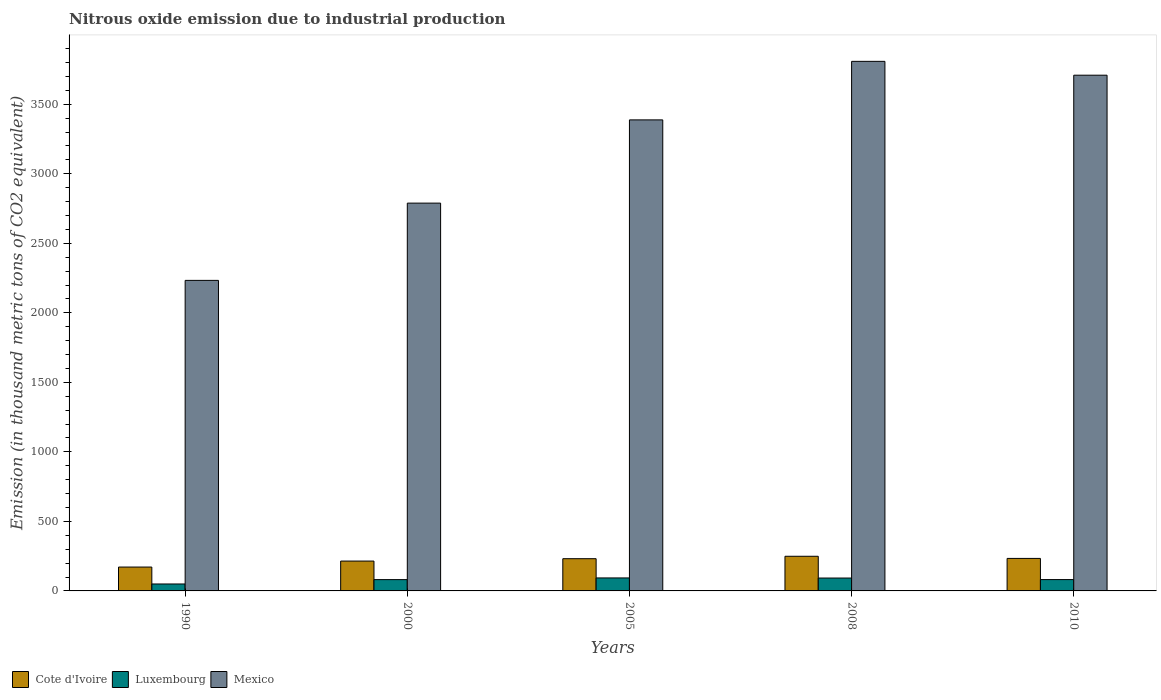What is the label of the 1st group of bars from the left?
Your answer should be very brief. 1990. In how many cases, is the number of bars for a given year not equal to the number of legend labels?
Make the answer very short. 0. What is the amount of nitrous oxide emitted in Mexico in 2000?
Ensure brevity in your answer.  2789.1. Across all years, what is the maximum amount of nitrous oxide emitted in Mexico?
Provide a succinct answer. 3808.7. Across all years, what is the minimum amount of nitrous oxide emitted in Cote d'Ivoire?
Your answer should be very brief. 171.6. In which year was the amount of nitrous oxide emitted in Mexico maximum?
Offer a terse response. 2008. What is the total amount of nitrous oxide emitted in Luxembourg in the graph?
Give a very brief answer. 398.7. What is the difference between the amount of nitrous oxide emitted in Mexico in 2008 and that in 2010?
Make the answer very short. 99.5. What is the difference between the amount of nitrous oxide emitted in Luxembourg in 2000 and the amount of nitrous oxide emitted in Cote d'Ivoire in 2010?
Your answer should be very brief. -152.5. What is the average amount of nitrous oxide emitted in Mexico per year?
Offer a terse response. 3185.64. In the year 2008, what is the difference between the amount of nitrous oxide emitted in Luxembourg and amount of nitrous oxide emitted in Cote d'Ivoire?
Make the answer very short. -156.6. What is the ratio of the amount of nitrous oxide emitted in Luxembourg in 2005 to that in 2008?
Your answer should be compact. 1.01. What is the difference between the highest and the second highest amount of nitrous oxide emitted in Mexico?
Your answer should be compact. 99.5. What is the difference between the highest and the lowest amount of nitrous oxide emitted in Cote d'Ivoire?
Ensure brevity in your answer.  77.6. In how many years, is the amount of nitrous oxide emitted in Luxembourg greater than the average amount of nitrous oxide emitted in Luxembourg taken over all years?
Provide a short and direct response. 4. What does the 3rd bar from the right in 2005 represents?
Provide a short and direct response. Cote d'Ivoire. How many bars are there?
Give a very brief answer. 15. Does the graph contain grids?
Offer a very short reply. No. Where does the legend appear in the graph?
Provide a short and direct response. Bottom left. How are the legend labels stacked?
Give a very brief answer. Horizontal. What is the title of the graph?
Offer a terse response. Nitrous oxide emission due to industrial production. Does "Papua New Guinea" appear as one of the legend labels in the graph?
Offer a terse response. No. What is the label or title of the X-axis?
Give a very brief answer. Years. What is the label or title of the Y-axis?
Provide a short and direct response. Emission (in thousand metric tons of CO2 equivalent). What is the Emission (in thousand metric tons of CO2 equivalent) of Cote d'Ivoire in 1990?
Provide a short and direct response. 171.6. What is the Emission (in thousand metric tons of CO2 equivalent) in Luxembourg in 1990?
Your answer should be very brief. 49.9. What is the Emission (in thousand metric tons of CO2 equivalent) in Mexico in 1990?
Give a very brief answer. 2233.4. What is the Emission (in thousand metric tons of CO2 equivalent) of Cote d'Ivoire in 2000?
Your response must be concise. 214.7. What is the Emission (in thousand metric tons of CO2 equivalent) in Luxembourg in 2000?
Your answer should be compact. 81.3. What is the Emission (in thousand metric tons of CO2 equivalent) of Mexico in 2000?
Give a very brief answer. 2789.1. What is the Emission (in thousand metric tons of CO2 equivalent) of Cote d'Ivoire in 2005?
Offer a terse response. 231.8. What is the Emission (in thousand metric tons of CO2 equivalent) in Luxembourg in 2005?
Keep it short and to the point. 93.4. What is the Emission (in thousand metric tons of CO2 equivalent) of Mexico in 2005?
Ensure brevity in your answer.  3387.8. What is the Emission (in thousand metric tons of CO2 equivalent) in Cote d'Ivoire in 2008?
Keep it short and to the point. 249.2. What is the Emission (in thousand metric tons of CO2 equivalent) in Luxembourg in 2008?
Offer a terse response. 92.6. What is the Emission (in thousand metric tons of CO2 equivalent) in Mexico in 2008?
Give a very brief answer. 3808.7. What is the Emission (in thousand metric tons of CO2 equivalent) in Cote d'Ivoire in 2010?
Provide a short and direct response. 233.8. What is the Emission (in thousand metric tons of CO2 equivalent) of Luxembourg in 2010?
Ensure brevity in your answer.  81.5. What is the Emission (in thousand metric tons of CO2 equivalent) of Mexico in 2010?
Provide a short and direct response. 3709.2. Across all years, what is the maximum Emission (in thousand metric tons of CO2 equivalent) of Cote d'Ivoire?
Provide a succinct answer. 249.2. Across all years, what is the maximum Emission (in thousand metric tons of CO2 equivalent) of Luxembourg?
Keep it short and to the point. 93.4. Across all years, what is the maximum Emission (in thousand metric tons of CO2 equivalent) of Mexico?
Your response must be concise. 3808.7. Across all years, what is the minimum Emission (in thousand metric tons of CO2 equivalent) of Cote d'Ivoire?
Your response must be concise. 171.6. Across all years, what is the minimum Emission (in thousand metric tons of CO2 equivalent) in Luxembourg?
Your answer should be very brief. 49.9. Across all years, what is the minimum Emission (in thousand metric tons of CO2 equivalent) of Mexico?
Give a very brief answer. 2233.4. What is the total Emission (in thousand metric tons of CO2 equivalent) of Cote d'Ivoire in the graph?
Your answer should be very brief. 1101.1. What is the total Emission (in thousand metric tons of CO2 equivalent) in Luxembourg in the graph?
Your response must be concise. 398.7. What is the total Emission (in thousand metric tons of CO2 equivalent) in Mexico in the graph?
Ensure brevity in your answer.  1.59e+04. What is the difference between the Emission (in thousand metric tons of CO2 equivalent) in Cote d'Ivoire in 1990 and that in 2000?
Offer a terse response. -43.1. What is the difference between the Emission (in thousand metric tons of CO2 equivalent) of Luxembourg in 1990 and that in 2000?
Your answer should be very brief. -31.4. What is the difference between the Emission (in thousand metric tons of CO2 equivalent) in Mexico in 1990 and that in 2000?
Offer a terse response. -555.7. What is the difference between the Emission (in thousand metric tons of CO2 equivalent) of Cote d'Ivoire in 1990 and that in 2005?
Your answer should be very brief. -60.2. What is the difference between the Emission (in thousand metric tons of CO2 equivalent) of Luxembourg in 1990 and that in 2005?
Your answer should be compact. -43.5. What is the difference between the Emission (in thousand metric tons of CO2 equivalent) of Mexico in 1990 and that in 2005?
Make the answer very short. -1154.4. What is the difference between the Emission (in thousand metric tons of CO2 equivalent) of Cote d'Ivoire in 1990 and that in 2008?
Make the answer very short. -77.6. What is the difference between the Emission (in thousand metric tons of CO2 equivalent) of Luxembourg in 1990 and that in 2008?
Your response must be concise. -42.7. What is the difference between the Emission (in thousand metric tons of CO2 equivalent) in Mexico in 1990 and that in 2008?
Your answer should be very brief. -1575.3. What is the difference between the Emission (in thousand metric tons of CO2 equivalent) in Cote d'Ivoire in 1990 and that in 2010?
Offer a terse response. -62.2. What is the difference between the Emission (in thousand metric tons of CO2 equivalent) in Luxembourg in 1990 and that in 2010?
Keep it short and to the point. -31.6. What is the difference between the Emission (in thousand metric tons of CO2 equivalent) in Mexico in 1990 and that in 2010?
Ensure brevity in your answer.  -1475.8. What is the difference between the Emission (in thousand metric tons of CO2 equivalent) of Cote d'Ivoire in 2000 and that in 2005?
Your answer should be compact. -17.1. What is the difference between the Emission (in thousand metric tons of CO2 equivalent) of Luxembourg in 2000 and that in 2005?
Your response must be concise. -12.1. What is the difference between the Emission (in thousand metric tons of CO2 equivalent) in Mexico in 2000 and that in 2005?
Give a very brief answer. -598.7. What is the difference between the Emission (in thousand metric tons of CO2 equivalent) in Cote d'Ivoire in 2000 and that in 2008?
Keep it short and to the point. -34.5. What is the difference between the Emission (in thousand metric tons of CO2 equivalent) of Luxembourg in 2000 and that in 2008?
Your answer should be very brief. -11.3. What is the difference between the Emission (in thousand metric tons of CO2 equivalent) in Mexico in 2000 and that in 2008?
Your answer should be compact. -1019.6. What is the difference between the Emission (in thousand metric tons of CO2 equivalent) of Cote d'Ivoire in 2000 and that in 2010?
Offer a terse response. -19.1. What is the difference between the Emission (in thousand metric tons of CO2 equivalent) of Luxembourg in 2000 and that in 2010?
Your answer should be compact. -0.2. What is the difference between the Emission (in thousand metric tons of CO2 equivalent) of Mexico in 2000 and that in 2010?
Make the answer very short. -920.1. What is the difference between the Emission (in thousand metric tons of CO2 equivalent) of Cote d'Ivoire in 2005 and that in 2008?
Your response must be concise. -17.4. What is the difference between the Emission (in thousand metric tons of CO2 equivalent) of Mexico in 2005 and that in 2008?
Your answer should be compact. -420.9. What is the difference between the Emission (in thousand metric tons of CO2 equivalent) of Mexico in 2005 and that in 2010?
Keep it short and to the point. -321.4. What is the difference between the Emission (in thousand metric tons of CO2 equivalent) of Luxembourg in 2008 and that in 2010?
Your response must be concise. 11.1. What is the difference between the Emission (in thousand metric tons of CO2 equivalent) of Mexico in 2008 and that in 2010?
Give a very brief answer. 99.5. What is the difference between the Emission (in thousand metric tons of CO2 equivalent) of Cote d'Ivoire in 1990 and the Emission (in thousand metric tons of CO2 equivalent) of Luxembourg in 2000?
Your response must be concise. 90.3. What is the difference between the Emission (in thousand metric tons of CO2 equivalent) of Cote d'Ivoire in 1990 and the Emission (in thousand metric tons of CO2 equivalent) of Mexico in 2000?
Keep it short and to the point. -2617.5. What is the difference between the Emission (in thousand metric tons of CO2 equivalent) in Luxembourg in 1990 and the Emission (in thousand metric tons of CO2 equivalent) in Mexico in 2000?
Your response must be concise. -2739.2. What is the difference between the Emission (in thousand metric tons of CO2 equivalent) of Cote d'Ivoire in 1990 and the Emission (in thousand metric tons of CO2 equivalent) of Luxembourg in 2005?
Provide a succinct answer. 78.2. What is the difference between the Emission (in thousand metric tons of CO2 equivalent) of Cote d'Ivoire in 1990 and the Emission (in thousand metric tons of CO2 equivalent) of Mexico in 2005?
Offer a terse response. -3216.2. What is the difference between the Emission (in thousand metric tons of CO2 equivalent) in Luxembourg in 1990 and the Emission (in thousand metric tons of CO2 equivalent) in Mexico in 2005?
Your answer should be very brief. -3337.9. What is the difference between the Emission (in thousand metric tons of CO2 equivalent) in Cote d'Ivoire in 1990 and the Emission (in thousand metric tons of CO2 equivalent) in Luxembourg in 2008?
Keep it short and to the point. 79. What is the difference between the Emission (in thousand metric tons of CO2 equivalent) of Cote d'Ivoire in 1990 and the Emission (in thousand metric tons of CO2 equivalent) of Mexico in 2008?
Provide a short and direct response. -3637.1. What is the difference between the Emission (in thousand metric tons of CO2 equivalent) in Luxembourg in 1990 and the Emission (in thousand metric tons of CO2 equivalent) in Mexico in 2008?
Offer a terse response. -3758.8. What is the difference between the Emission (in thousand metric tons of CO2 equivalent) in Cote d'Ivoire in 1990 and the Emission (in thousand metric tons of CO2 equivalent) in Luxembourg in 2010?
Provide a short and direct response. 90.1. What is the difference between the Emission (in thousand metric tons of CO2 equivalent) in Cote d'Ivoire in 1990 and the Emission (in thousand metric tons of CO2 equivalent) in Mexico in 2010?
Make the answer very short. -3537.6. What is the difference between the Emission (in thousand metric tons of CO2 equivalent) in Luxembourg in 1990 and the Emission (in thousand metric tons of CO2 equivalent) in Mexico in 2010?
Provide a short and direct response. -3659.3. What is the difference between the Emission (in thousand metric tons of CO2 equivalent) in Cote d'Ivoire in 2000 and the Emission (in thousand metric tons of CO2 equivalent) in Luxembourg in 2005?
Your answer should be very brief. 121.3. What is the difference between the Emission (in thousand metric tons of CO2 equivalent) of Cote d'Ivoire in 2000 and the Emission (in thousand metric tons of CO2 equivalent) of Mexico in 2005?
Your answer should be very brief. -3173.1. What is the difference between the Emission (in thousand metric tons of CO2 equivalent) of Luxembourg in 2000 and the Emission (in thousand metric tons of CO2 equivalent) of Mexico in 2005?
Your answer should be very brief. -3306.5. What is the difference between the Emission (in thousand metric tons of CO2 equivalent) in Cote d'Ivoire in 2000 and the Emission (in thousand metric tons of CO2 equivalent) in Luxembourg in 2008?
Offer a very short reply. 122.1. What is the difference between the Emission (in thousand metric tons of CO2 equivalent) in Cote d'Ivoire in 2000 and the Emission (in thousand metric tons of CO2 equivalent) in Mexico in 2008?
Make the answer very short. -3594. What is the difference between the Emission (in thousand metric tons of CO2 equivalent) of Luxembourg in 2000 and the Emission (in thousand metric tons of CO2 equivalent) of Mexico in 2008?
Keep it short and to the point. -3727.4. What is the difference between the Emission (in thousand metric tons of CO2 equivalent) of Cote d'Ivoire in 2000 and the Emission (in thousand metric tons of CO2 equivalent) of Luxembourg in 2010?
Provide a short and direct response. 133.2. What is the difference between the Emission (in thousand metric tons of CO2 equivalent) of Cote d'Ivoire in 2000 and the Emission (in thousand metric tons of CO2 equivalent) of Mexico in 2010?
Give a very brief answer. -3494.5. What is the difference between the Emission (in thousand metric tons of CO2 equivalent) in Luxembourg in 2000 and the Emission (in thousand metric tons of CO2 equivalent) in Mexico in 2010?
Provide a succinct answer. -3627.9. What is the difference between the Emission (in thousand metric tons of CO2 equivalent) of Cote d'Ivoire in 2005 and the Emission (in thousand metric tons of CO2 equivalent) of Luxembourg in 2008?
Offer a terse response. 139.2. What is the difference between the Emission (in thousand metric tons of CO2 equivalent) of Cote d'Ivoire in 2005 and the Emission (in thousand metric tons of CO2 equivalent) of Mexico in 2008?
Provide a succinct answer. -3576.9. What is the difference between the Emission (in thousand metric tons of CO2 equivalent) in Luxembourg in 2005 and the Emission (in thousand metric tons of CO2 equivalent) in Mexico in 2008?
Your response must be concise. -3715.3. What is the difference between the Emission (in thousand metric tons of CO2 equivalent) in Cote d'Ivoire in 2005 and the Emission (in thousand metric tons of CO2 equivalent) in Luxembourg in 2010?
Keep it short and to the point. 150.3. What is the difference between the Emission (in thousand metric tons of CO2 equivalent) in Cote d'Ivoire in 2005 and the Emission (in thousand metric tons of CO2 equivalent) in Mexico in 2010?
Your response must be concise. -3477.4. What is the difference between the Emission (in thousand metric tons of CO2 equivalent) of Luxembourg in 2005 and the Emission (in thousand metric tons of CO2 equivalent) of Mexico in 2010?
Keep it short and to the point. -3615.8. What is the difference between the Emission (in thousand metric tons of CO2 equivalent) of Cote d'Ivoire in 2008 and the Emission (in thousand metric tons of CO2 equivalent) of Luxembourg in 2010?
Make the answer very short. 167.7. What is the difference between the Emission (in thousand metric tons of CO2 equivalent) in Cote d'Ivoire in 2008 and the Emission (in thousand metric tons of CO2 equivalent) in Mexico in 2010?
Provide a succinct answer. -3460. What is the difference between the Emission (in thousand metric tons of CO2 equivalent) in Luxembourg in 2008 and the Emission (in thousand metric tons of CO2 equivalent) in Mexico in 2010?
Provide a succinct answer. -3616.6. What is the average Emission (in thousand metric tons of CO2 equivalent) of Cote d'Ivoire per year?
Ensure brevity in your answer.  220.22. What is the average Emission (in thousand metric tons of CO2 equivalent) of Luxembourg per year?
Your response must be concise. 79.74. What is the average Emission (in thousand metric tons of CO2 equivalent) of Mexico per year?
Give a very brief answer. 3185.64. In the year 1990, what is the difference between the Emission (in thousand metric tons of CO2 equivalent) in Cote d'Ivoire and Emission (in thousand metric tons of CO2 equivalent) in Luxembourg?
Your answer should be compact. 121.7. In the year 1990, what is the difference between the Emission (in thousand metric tons of CO2 equivalent) of Cote d'Ivoire and Emission (in thousand metric tons of CO2 equivalent) of Mexico?
Offer a terse response. -2061.8. In the year 1990, what is the difference between the Emission (in thousand metric tons of CO2 equivalent) in Luxembourg and Emission (in thousand metric tons of CO2 equivalent) in Mexico?
Your answer should be very brief. -2183.5. In the year 2000, what is the difference between the Emission (in thousand metric tons of CO2 equivalent) of Cote d'Ivoire and Emission (in thousand metric tons of CO2 equivalent) of Luxembourg?
Ensure brevity in your answer.  133.4. In the year 2000, what is the difference between the Emission (in thousand metric tons of CO2 equivalent) of Cote d'Ivoire and Emission (in thousand metric tons of CO2 equivalent) of Mexico?
Your response must be concise. -2574.4. In the year 2000, what is the difference between the Emission (in thousand metric tons of CO2 equivalent) in Luxembourg and Emission (in thousand metric tons of CO2 equivalent) in Mexico?
Offer a terse response. -2707.8. In the year 2005, what is the difference between the Emission (in thousand metric tons of CO2 equivalent) in Cote d'Ivoire and Emission (in thousand metric tons of CO2 equivalent) in Luxembourg?
Give a very brief answer. 138.4. In the year 2005, what is the difference between the Emission (in thousand metric tons of CO2 equivalent) in Cote d'Ivoire and Emission (in thousand metric tons of CO2 equivalent) in Mexico?
Provide a short and direct response. -3156. In the year 2005, what is the difference between the Emission (in thousand metric tons of CO2 equivalent) of Luxembourg and Emission (in thousand metric tons of CO2 equivalent) of Mexico?
Provide a succinct answer. -3294.4. In the year 2008, what is the difference between the Emission (in thousand metric tons of CO2 equivalent) in Cote d'Ivoire and Emission (in thousand metric tons of CO2 equivalent) in Luxembourg?
Provide a succinct answer. 156.6. In the year 2008, what is the difference between the Emission (in thousand metric tons of CO2 equivalent) in Cote d'Ivoire and Emission (in thousand metric tons of CO2 equivalent) in Mexico?
Ensure brevity in your answer.  -3559.5. In the year 2008, what is the difference between the Emission (in thousand metric tons of CO2 equivalent) in Luxembourg and Emission (in thousand metric tons of CO2 equivalent) in Mexico?
Offer a terse response. -3716.1. In the year 2010, what is the difference between the Emission (in thousand metric tons of CO2 equivalent) of Cote d'Ivoire and Emission (in thousand metric tons of CO2 equivalent) of Luxembourg?
Ensure brevity in your answer.  152.3. In the year 2010, what is the difference between the Emission (in thousand metric tons of CO2 equivalent) in Cote d'Ivoire and Emission (in thousand metric tons of CO2 equivalent) in Mexico?
Ensure brevity in your answer.  -3475.4. In the year 2010, what is the difference between the Emission (in thousand metric tons of CO2 equivalent) of Luxembourg and Emission (in thousand metric tons of CO2 equivalent) of Mexico?
Your answer should be very brief. -3627.7. What is the ratio of the Emission (in thousand metric tons of CO2 equivalent) of Cote d'Ivoire in 1990 to that in 2000?
Offer a very short reply. 0.8. What is the ratio of the Emission (in thousand metric tons of CO2 equivalent) of Luxembourg in 1990 to that in 2000?
Provide a short and direct response. 0.61. What is the ratio of the Emission (in thousand metric tons of CO2 equivalent) in Mexico in 1990 to that in 2000?
Offer a very short reply. 0.8. What is the ratio of the Emission (in thousand metric tons of CO2 equivalent) of Cote d'Ivoire in 1990 to that in 2005?
Offer a terse response. 0.74. What is the ratio of the Emission (in thousand metric tons of CO2 equivalent) in Luxembourg in 1990 to that in 2005?
Give a very brief answer. 0.53. What is the ratio of the Emission (in thousand metric tons of CO2 equivalent) of Mexico in 1990 to that in 2005?
Your answer should be compact. 0.66. What is the ratio of the Emission (in thousand metric tons of CO2 equivalent) of Cote d'Ivoire in 1990 to that in 2008?
Give a very brief answer. 0.69. What is the ratio of the Emission (in thousand metric tons of CO2 equivalent) in Luxembourg in 1990 to that in 2008?
Ensure brevity in your answer.  0.54. What is the ratio of the Emission (in thousand metric tons of CO2 equivalent) of Mexico in 1990 to that in 2008?
Keep it short and to the point. 0.59. What is the ratio of the Emission (in thousand metric tons of CO2 equivalent) of Cote d'Ivoire in 1990 to that in 2010?
Your answer should be very brief. 0.73. What is the ratio of the Emission (in thousand metric tons of CO2 equivalent) in Luxembourg in 1990 to that in 2010?
Make the answer very short. 0.61. What is the ratio of the Emission (in thousand metric tons of CO2 equivalent) of Mexico in 1990 to that in 2010?
Ensure brevity in your answer.  0.6. What is the ratio of the Emission (in thousand metric tons of CO2 equivalent) of Cote d'Ivoire in 2000 to that in 2005?
Keep it short and to the point. 0.93. What is the ratio of the Emission (in thousand metric tons of CO2 equivalent) in Luxembourg in 2000 to that in 2005?
Give a very brief answer. 0.87. What is the ratio of the Emission (in thousand metric tons of CO2 equivalent) in Mexico in 2000 to that in 2005?
Your response must be concise. 0.82. What is the ratio of the Emission (in thousand metric tons of CO2 equivalent) in Cote d'Ivoire in 2000 to that in 2008?
Provide a short and direct response. 0.86. What is the ratio of the Emission (in thousand metric tons of CO2 equivalent) of Luxembourg in 2000 to that in 2008?
Ensure brevity in your answer.  0.88. What is the ratio of the Emission (in thousand metric tons of CO2 equivalent) of Mexico in 2000 to that in 2008?
Provide a succinct answer. 0.73. What is the ratio of the Emission (in thousand metric tons of CO2 equivalent) of Cote d'Ivoire in 2000 to that in 2010?
Offer a terse response. 0.92. What is the ratio of the Emission (in thousand metric tons of CO2 equivalent) in Mexico in 2000 to that in 2010?
Provide a succinct answer. 0.75. What is the ratio of the Emission (in thousand metric tons of CO2 equivalent) in Cote d'Ivoire in 2005 to that in 2008?
Offer a very short reply. 0.93. What is the ratio of the Emission (in thousand metric tons of CO2 equivalent) of Luxembourg in 2005 to that in 2008?
Ensure brevity in your answer.  1.01. What is the ratio of the Emission (in thousand metric tons of CO2 equivalent) of Mexico in 2005 to that in 2008?
Offer a very short reply. 0.89. What is the ratio of the Emission (in thousand metric tons of CO2 equivalent) in Cote d'Ivoire in 2005 to that in 2010?
Give a very brief answer. 0.99. What is the ratio of the Emission (in thousand metric tons of CO2 equivalent) in Luxembourg in 2005 to that in 2010?
Give a very brief answer. 1.15. What is the ratio of the Emission (in thousand metric tons of CO2 equivalent) of Mexico in 2005 to that in 2010?
Make the answer very short. 0.91. What is the ratio of the Emission (in thousand metric tons of CO2 equivalent) of Cote d'Ivoire in 2008 to that in 2010?
Your answer should be very brief. 1.07. What is the ratio of the Emission (in thousand metric tons of CO2 equivalent) of Luxembourg in 2008 to that in 2010?
Your response must be concise. 1.14. What is the ratio of the Emission (in thousand metric tons of CO2 equivalent) in Mexico in 2008 to that in 2010?
Give a very brief answer. 1.03. What is the difference between the highest and the second highest Emission (in thousand metric tons of CO2 equivalent) in Mexico?
Your response must be concise. 99.5. What is the difference between the highest and the lowest Emission (in thousand metric tons of CO2 equivalent) of Cote d'Ivoire?
Your response must be concise. 77.6. What is the difference between the highest and the lowest Emission (in thousand metric tons of CO2 equivalent) of Luxembourg?
Your response must be concise. 43.5. What is the difference between the highest and the lowest Emission (in thousand metric tons of CO2 equivalent) of Mexico?
Your answer should be compact. 1575.3. 